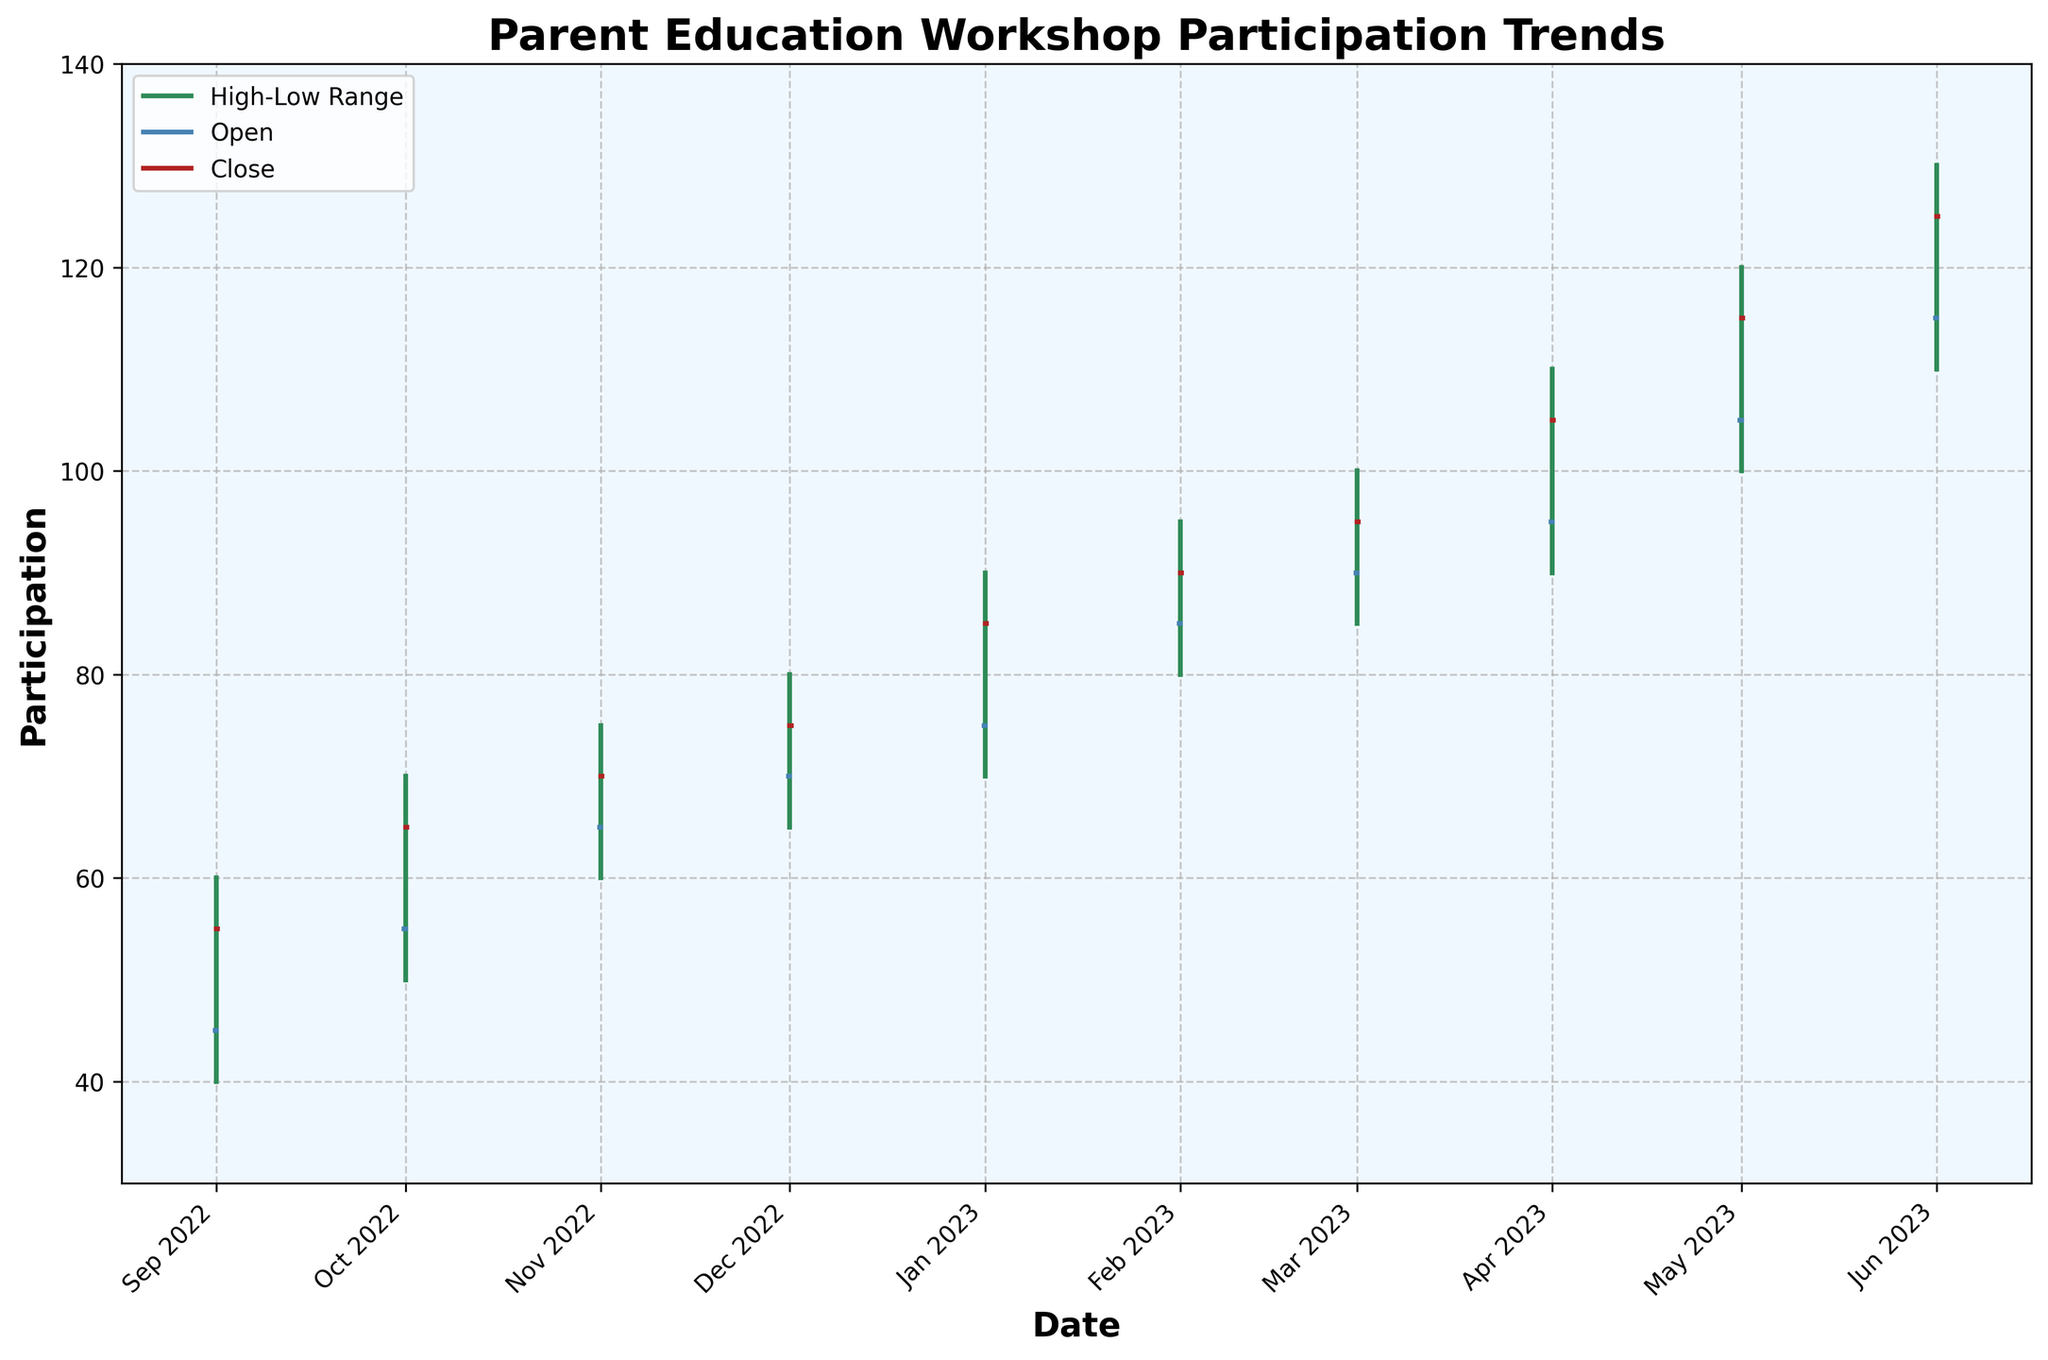What's the title of the chart? The title is displayed at the top of the figure, which reads "Parent Education Workshop Participation Trends".
Answer: Parent Education Workshop Participation Trends What is the highest participation value in May 2023? The highest participation value is identified using the "High" point for May 2023. According to the data, it is 120.
Answer: 120 Which month had the lowest participation among the recorded data? The lowest participation value for each month can be found in the "Low" series. The minimum value recorded throughout is 40, which belongs to September 2022.
Answer: September 2022 What is the total change in the "Close" value from February 2023 to June 2023? To find the net change in "Close" values between February and June 2023, subtract the February "Close" value from the June "Close" value: 125 - 90.
Answer: 35 What is the average "Open" value for the entire period? To find the average "Open" value, sum the values and divide by the number of months: (45+55+65+70+75+85+90+95+105+115)/10 = 80.
Answer: 80 How does the "Close" value for April 2023 compare with the "Open" value for the same month? The "Close" and "Open" values for April 2023 are 105 and 95 respectively. Compare these values: 105 is greater than 95.
Answer: The "Close" value is higher than the "Open" value What can you infer about the trend in participation from September 2022 to June 2023 based on the "Close" values? The "Close" values show an increment month by month from September 2022 (55) to June 2023 (125). This consistent increase reflects a growing trend in participation over the school year.
Answer: Increasing trend 